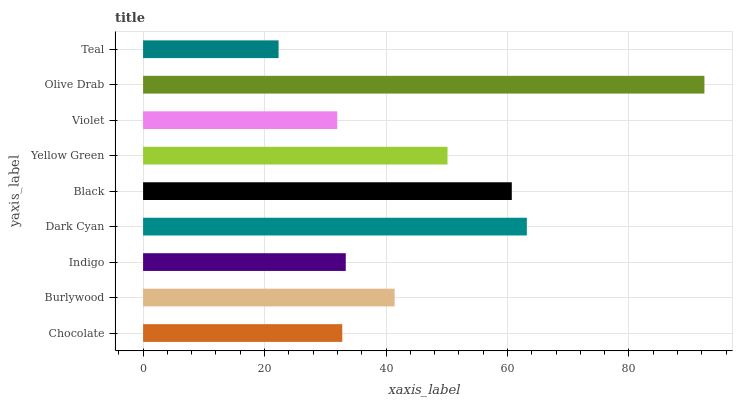Is Teal the minimum?
Answer yes or no. Yes. Is Olive Drab the maximum?
Answer yes or no. Yes. Is Burlywood the minimum?
Answer yes or no. No. Is Burlywood the maximum?
Answer yes or no. No. Is Burlywood greater than Chocolate?
Answer yes or no. Yes. Is Chocolate less than Burlywood?
Answer yes or no. Yes. Is Chocolate greater than Burlywood?
Answer yes or no. No. Is Burlywood less than Chocolate?
Answer yes or no. No. Is Burlywood the high median?
Answer yes or no. Yes. Is Burlywood the low median?
Answer yes or no. Yes. Is Yellow Green the high median?
Answer yes or no. No. Is Yellow Green the low median?
Answer yes or no. No. 